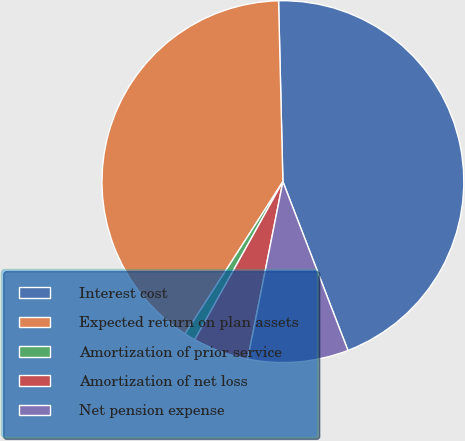Convert chart to OTSL. <chart><loc_0><loc_0><loc_500><loc_500><pie_chart><fcel>Interest cost<fcel>Expected return on plan assets<fcel>Amortization of prior service<fcel>Amortization of net loss<fcel>Net pension expense<nl><fcel>44.52%<fcel>40.53%<fcel>0.99%<fcel>4.98%<fcel>8.97%<nl></chart> 